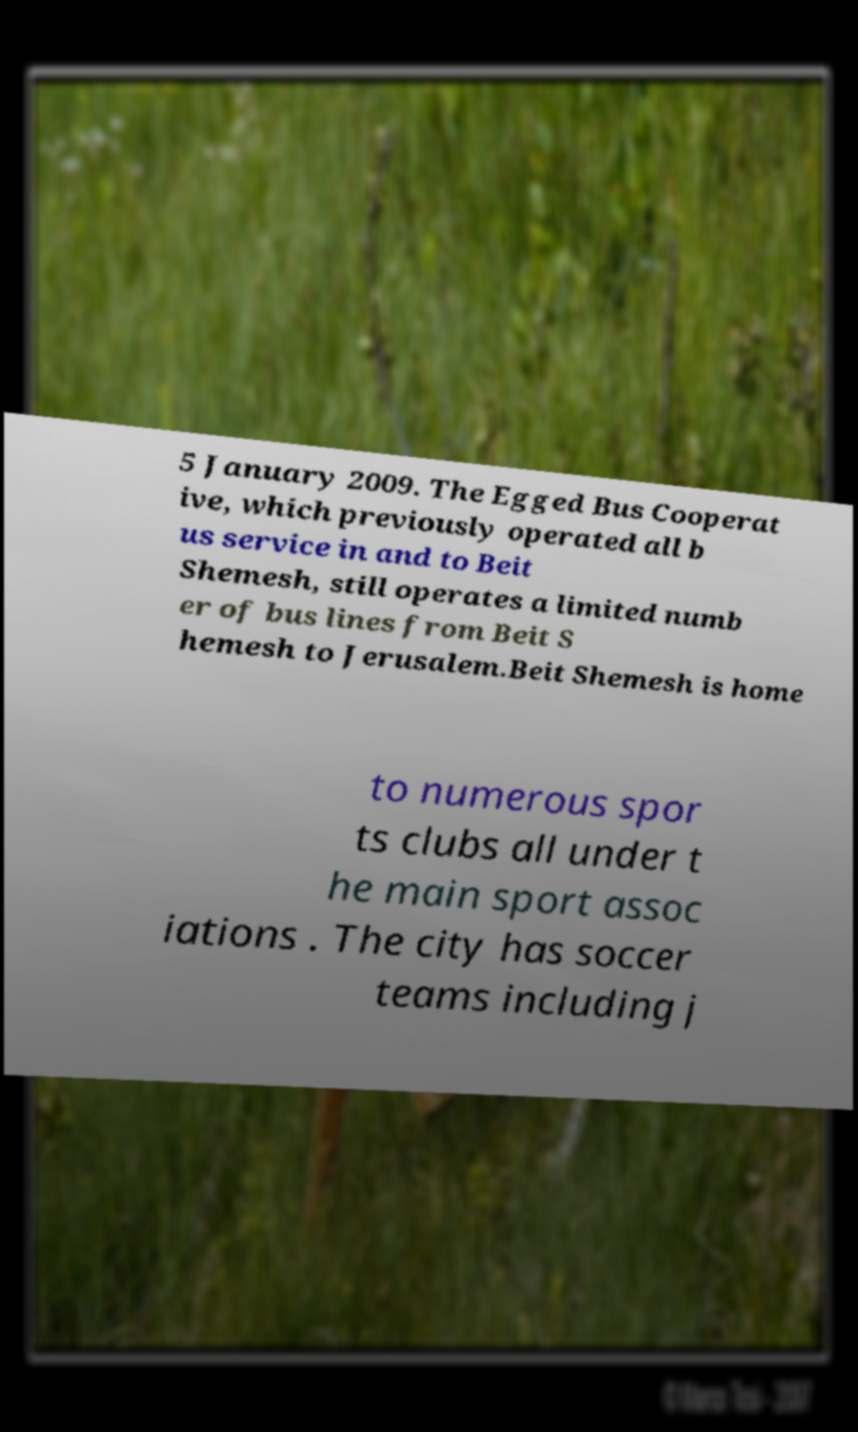I need the written content from this picture converted into text. Can you do that? 5 January 2009. The Egged Bus Cooperat ive, which previously operated all b us service in and to Beit Shemesh, still operates a limited numb er of bus lines from Beit S hemesh to Jerusalem.Beit Shemesh is home to numerous spor ts clubs all under t he main sport assoc iations . The city has soccer teams including j 